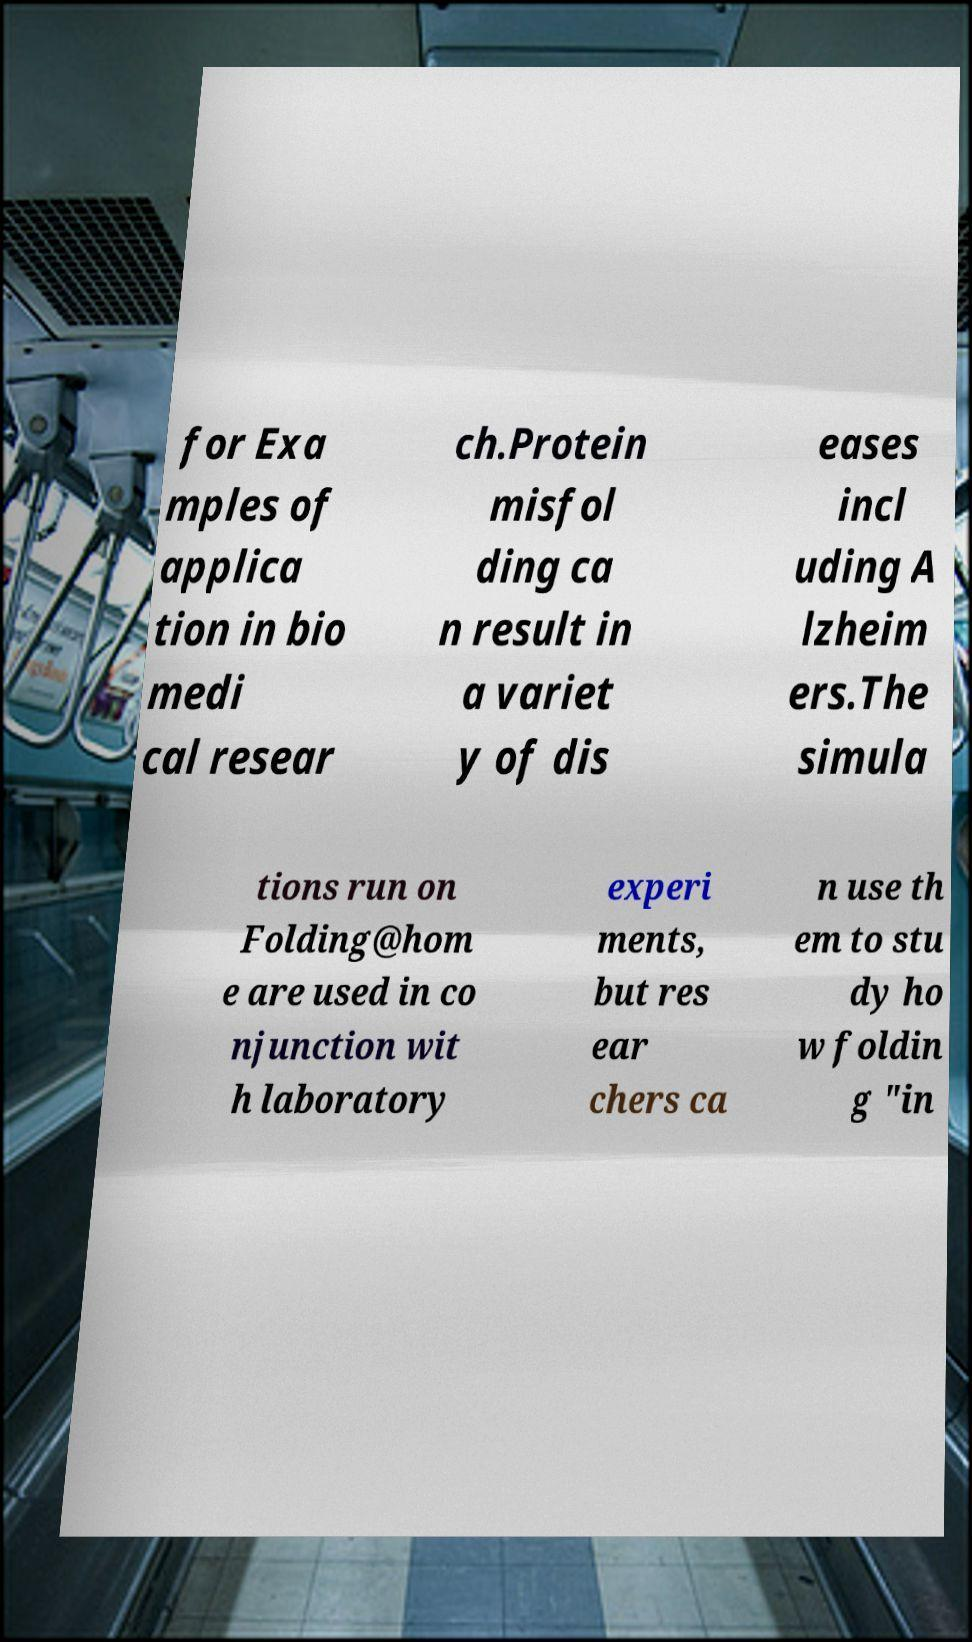Please read and relay the text visible in this image. What does it say? for Exa mples of applica tion in bio medi cal resear ch.Protein misfol ding ca n result in a variet y of dis eases incl uding A lzheim ers.The simula tions run on Folding@hom e are used in co njunction wit h laboratory experi ments, but res ear chers ca n use th em to stu dy ho w foldin g "in 